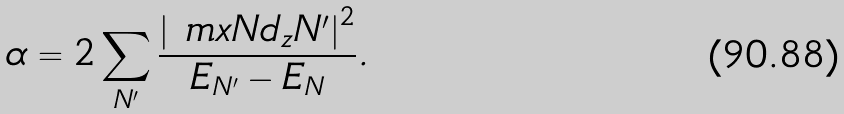Convert formula to latex. <formula><loc_0><loc_0><loc_500><loc_500>\alpha = 2 \sum _ { N ^ { \prime } } \frac { \left | \ m x { N } { d _ { z } } { N ^ { \prime } } \right | ^ { 2 } } { E _ { N ^ { \prime } } - E _ { N } } .</formula> 